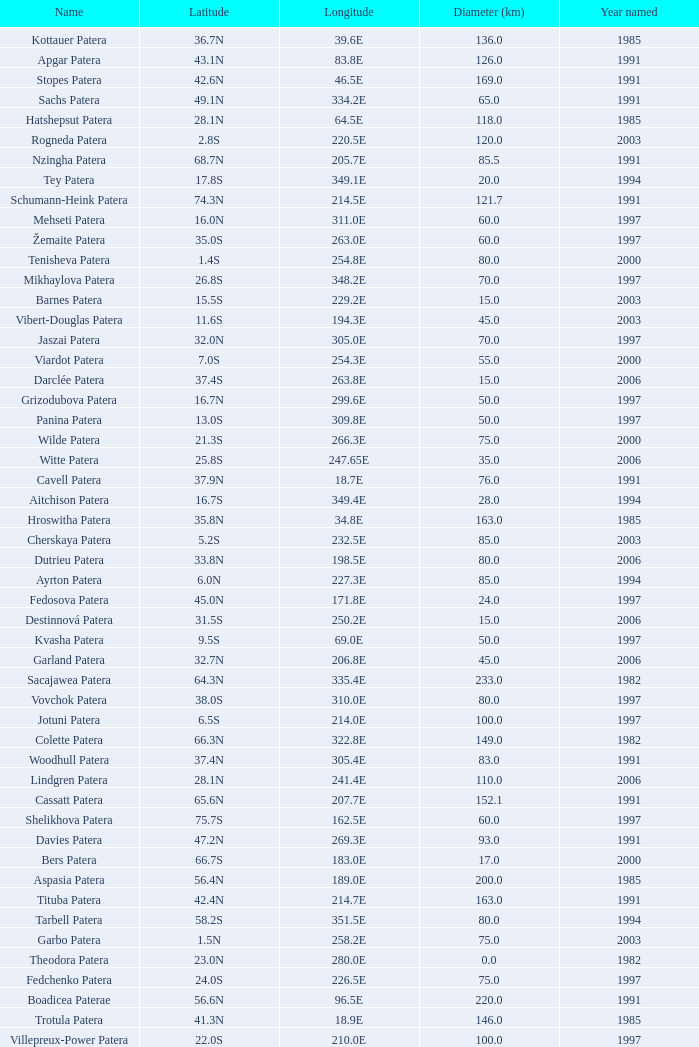What is Year Named, when Longitude is 227.5E? 1997.0. 